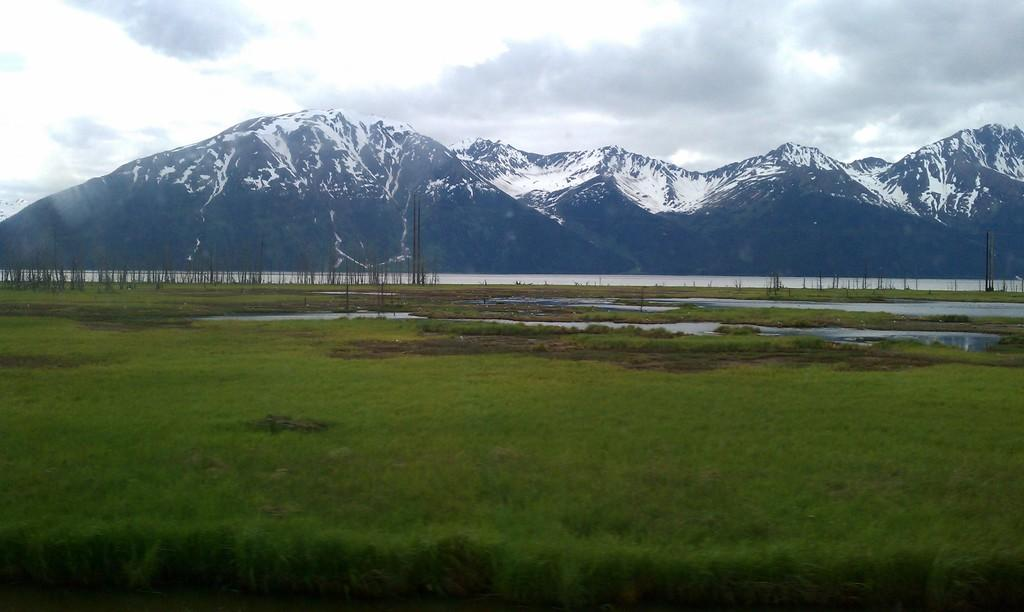What type of natural landform can be seen in the image? There are mountains in the image. What body of water is visible in the image? There is a water surface visible in the image. What type of vegetation is present on the ground in the image? There is grass on the ground in the image. What can be seen in the sky at the top of the image? Clouds are present in the sky at the top of the image. How many quince are hanging from the trees in the image? There are no trees or quince present in the image; it features mountains, a water surface, grass, and clouds. What type of animal is using its toes to climb the mountains in the image? There are no animals or references to toes in the image; it only features mountains, a water surface, grass, and clouds. 